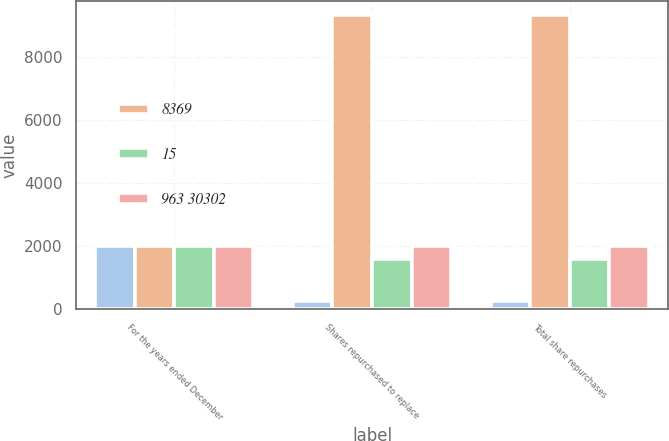Convert chart to OTSL. <chart><loc_0><loc_0><loc_500><loc_500><stacked_bar_chart><ecel><fcel>For the years ended December<fcel>Shares repurchased to replace<fcel>Total share repurchases<nl><fcel>nan<fcel>2009<fcel>252<fcel>252<nl><fcel>8369<fcel>2009<fcel>9314<fcel>9314<nl><fcel>15<fcel>2008<fcel>1610<fcel>1610<nl><fcel>963 30302<fcel>2008<fcel>2008<fcel>2008<nl></chart> 